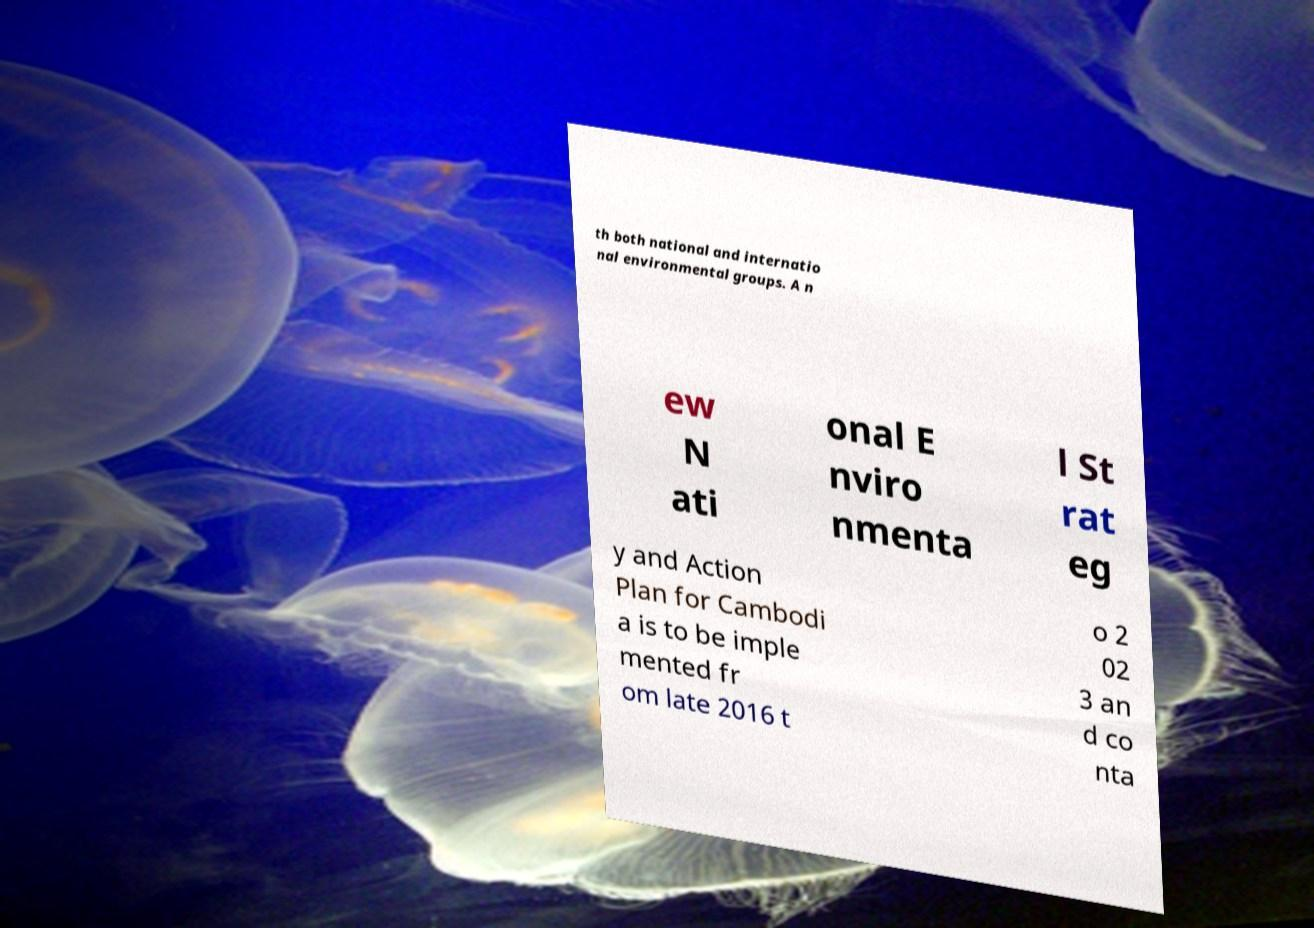What messages or text are displayed in this image? I need them in a readable, typed format. th both national and internatio nal environmental groups. A n ew N ati onal E nviro nmenta l St rat eg y and Action Plan for Cambodi a is to be imple mented fr om late 2016 t o 2 02 3 an d co nta 